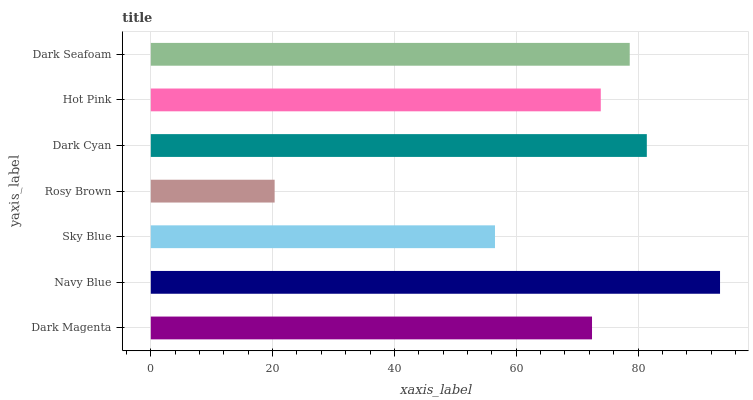Is Rosy Brown the minimum?
Answer yes or no. Yes. Is Navy Blue the maximum?
Answer yes or no. Yes. Is Sky Blue the minimum?
Answer yes or no. No. Is Sky Blue the maximum?
Answer yes or no. No. Is Navy Blue greater than Sky Blue?
Answer yes or no. Yes. Is Sky Blue less than Navy Blue?
Answer yes or no. Yes. Is Sky Blue greater than Navy Blue?
Answer yes or no. No. Is Navy Blue less than Sky Blue?
Answer yes or no. No. Is Hot Pink the high median?
Answer yes or no. Yes. Is Hot Pink the low median?
Answer yes or no. Yes. Is Dark Magenta the high median?
Answer yes or no. No. Is Dark Cyan the low median?
Answer yes or no. No. 